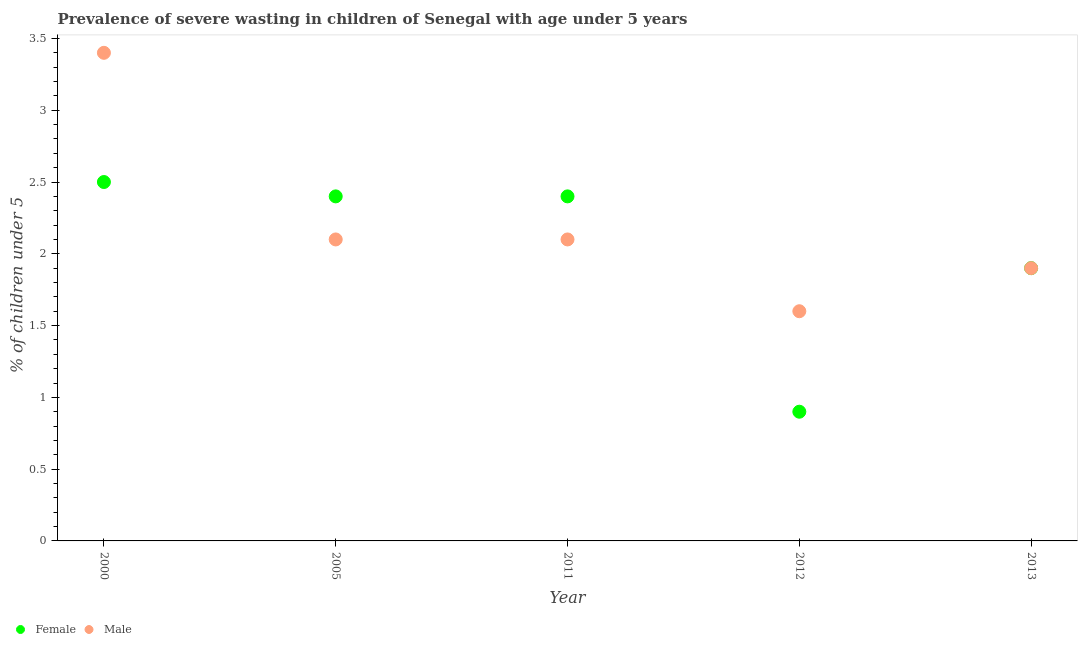Is the number of dotlines equal to the number of legend labels?
Your answer should be compact. Yes. What is the percentage of undernourished male children in 2000?
Give a very brief answer. 3.4. Across all years, what is the maximum percentage of undernourished female children?
Your answer should be very brief. 2.5. Across all years, what is the minimum percentage of undernourished female children?
Provide a short and direct response. 0.9. In which year was the percentage of undernourished male children minimum?
Keep it short and to the point. 2012. What is the total percentage of undernourished male children in the graph?
Give a very brief answer. 11.1. What is the difference between the percentage of undernourished male children in 2005 and that in 2012?
Give a very brief answer. 0.5. What is the difference between the percentage of undernourished male children in 2011 and the percentage of undernourished female children in 2000?
Ensure brevity in your answer.  -0.4. What is the average percentage of undernourished male children per year?
Your answer should be compact. 2.22. In the year 2000, what is the difference between the percentage of undernourished male children and percentage of undernourished female children?
Give a very brief answer. 0.9. In how many years, is the percentage of undernourished female children greater than 2.2 %?
Ensure brevity in your answer.  3. What is the ratio of the percentage of undernourished female children in 2000 to that in 2013?
Offer a very short reply. 1.32. Is the percentage of undernourished female children in 2005 less than that in 2012?
Offer a very short reply. No. Is the difference between the percentage of undernourished female children in 2005 and 2011 greater than the difference between the percentage of undernourished male children in 2005 and 2011?
Provide a succinct answer. No. What is the difference between the highest and the second highest percentage of undernourished male children?
Ensure brevity in your answer.  1.3. What is the difference between the highest and the lowest percentage of undernourished male children?
Ensure brevity in your answer.  1.8. Is the sum of the percentage of undernourished male children in 2005 and 2013 greater than the maximum percentage of undernourished female children across all years?
Ensure brevity in your answer.  Yes. How many dotlines are there?
Give a very brief answer. 2. How many years are there in the graph?
Offer a very short reply. 5. What is the difference between two consecutive major ticks on the Y-axis?
Provide a short and direct response. 0.5. Are the values on the major ticks of Y-axis written in scientific E-notation?
Make the answer very short. No. Does the graph contain grids?
Provide a succinct answer. No. Where does the legend appear in the graph?
Ensure brevity in your answer.  Bottom left. What is the title of the graph?
Your answer should be very brief. Prevalence of severe wasting in children of Senegal with age under 5 years. Does "Non-pregnant women" appear as one of the legend labels in the graph?
Keep it short and to the point. No. What is the label or title of the X-axis?
Keep it short and to the point. Year. What is the label or title of the Y-axis?
Provide a short and direct response.  % of children under 5. What is the  % of children under 5 in Male in 2000?
Offer a terse response. 3.4. What is the  % of children under 5 in Female in 2005?
Keep it short and to the point. 2.4. What is the  % of children under 5 in Male in 2005?
Give a very brief answer. 2.1. What is the  % of children under 5 of Female in 2011?
Make the answer very short. 2.4. What is the  % of children under 5 in Male in 2011?
Provide a short and direct response. 2.1. What is the  % of children under 5 of Female in 2012?
Your answer should be very brief. 0.9. What is the  % of children under 5 in Male in 2012?
Provide a short and direct response. 1.6. What is the  % of children under 5 of Female in 2013?
Provide a succinct answer. 1.9. What is the  % of children under 5 in Male in 2013?
Your answer should be compact. 1.9. Across all years, what is the maximum  % of children under 5 of Male?
Your answer should be compact. 3.4. Across all years, what is the minimum  % of children under 5 of Female?
Ensure brevity in your answer.  0.9. Across all years, what is the minimum  % of children under 5 of Male?
Ensure brevity in your answer.  1.6. What is the total  % of children under 5 of Female in the graph?
Offer a very short reply. 10.1. What is the difference between the  % of children under 5 of Female in 2000 and that in 2005?
Ensure brevity in your answer.  0.1. What is the difference between the  % of children under 5 in Male in 2000 and that in 2005?
Provide a short and direct response. 1.3. What is the difference between the  % of children under 5 in Male in 2000 and that in 2011?
Give a very brief answer. 1.3. What is the difference between the  % of children under 5 of Female in 2000 and that in 2012?
Make the answer very short. 1.6. What is the difference between the  % of children under 5 of Male in 2000 and that in 2012?
Give a very brief answer. 1.8. What is the difference between the  % of children under 5 of Female in 2000 and that in 2013?
Keep it short and to the point. 0.6. What is the difference between the  % of children under 5 in Female in 2005 and that in 2012?
Make the answer very short. 1.5. What is the difference between the  % of children under 5 of Male in 2005 and that in 2012?
Your answer should be very brief. 0.5. What is the difference between the  % of children under 5 of Female in 2005 and that in 2013?
Your answer should be compact. 0.5. What is the difference between the  % of children under 5 in Male in 2005 and that in 2013?
Your answer should be very brief. 0.2. What is the difference between the  % of children under 5 of Female in 2011 and that in 2013?
Your answer should be compact. 0.5. What is the difference between the  % of children under 5 of Male in 2011 and that in 2013?
Ensure brevity in your answer.  0.2. What is the difference between the  % of children under 5 of Male in 2012 and that in 2013?
Offer a very short reply. -0.3. What is the difference between the  % of children under 5 in Female in 2000 and the  % of children under 5 in Male in 2005?
Your answer should be very brief. 0.4. What is the difference between the  % of children under 5 in Female in 2000 and the  % of children under 5 in Male in 2011?
Keep it short and to the point. 0.4. What is the difference between the  % of children under 5 in Female in 2000 and the  % of children under 5 in Male in 2012?
Your response must be concise. 0.9. What is the difference between the  % of children under 5 in Female in 2000 and the  % of children under 5 in Male in 2013?
Offer a terse response. 0.6. What is the difference between the  % of children under 5 in Female in 2005 and the  % of children under 5 in Male in 2011?
Provide a short and direct response. 0.3. What is the difference between the  % of children under 5 in Female in 2005 and the  % of children under 5 in Male in 2013?
Your response must be concise. 0.5. What is the difference between the  % of children under 5 of Female in 2011 and the  % of children under 5 of Male in 2013?
Offer a very short reply. 0.5. What is the average  % of children under 5 in Female per year?
Make the answer very short. 2.02. What is the average  % of children under 5 in Male per year?
Your response must be concise. 2.22. In the year 2011, what is the difference between the  % of children under 5 of Female and  % of children under 5 of Male?
Ensure brevity in your answer.  0.3. In the year 2012, what is the difference between the  % of children under 5 in Female and  % of children under 5 in Male?
Your response must be concise. -0.7. In the year 2013, what is the difference between the  % of children under 5 of Female and  % of children under 5 of Male?
Offer a very short reply. 0. What is the ratio of the  % of children under 5 in Female in 2000 to that in 2005?
Make the answer very short. 1.04. What is the ratio of the  % of children under 5 in Male in 2000 to that in 2005?
Ensure brevity in your answer.  1.62. What is the ratio of the  % of children under 5 in Female in 2000 to that in 2011?
Provide a succinct answer. 1.04. What is the ratio of the  % of children under 5 in Male in 2000 to that in 2011?
Offer a terse response. 1.62. What is the ratio of the  % of children under 5 in Female in 2000 to that in 2012?
Give a very brief answer. 2.78. What is the ratio of the  % of children under 5 of Male in 2000 to that in 2012?
Ensure brevity in your answer.  2.12. What is the ratio of the  % of children under 5 of Female in 2000 to that in 2013?
Your answer should be compact. 1.32. What is the ratio of the  % of children under 5 in Male in 2000 to that in 2013?
Give a very brief answer. 1.79. What is the ratio of the  % of children under 5 in Male in 2005 to that in 2011?
Offer a very short reply. 1. What is the ratio of the  % of children under 5 of Female in 2005 to that in 2012?
Offer a very short reply. 2.67. What is the ratio of the  % of children under 5 of Male in 2005 to that in 2012?
Keep it short and to the point. 1.31. What is the ratio of the  % of children under 5 of Female in 2005 to that in 2013?
Ensure brevity in your answer.  1.26. What is the ratio of the  % of children under 5 of Male in 2005 to that in 2013?
Make the answer very short. 1.11. What is the ratio of the  % of children under 5 of Female in 2011 to that in 2012?
Ensure brevity in your answer.  2.67. What is the ratio of the  % of children under 5 of Male in 2011 to that in 2012?
Provide a short and direct response. 1.31. What is the ratio of the  % of children under 5 in Female in 2011 to that in 2013?
Give a very brief answer. 1.26. What is the ratio of the  % of children under 5 in Male in 2011 to that in 2013?
Provide a succinct answer. 1.11. What is the ratio of the  % of children under 5 of Female in 2012 to that in 2013?
Ensure brevity in your answer.  0.47. What is the ratio of the  % of children under 5 in Male in 2012 to that in 2013?
Offer a terse response. 0.84. What is the difference between the highest and the second highest  % of children under 5 in Female?
Provide a succinct answer. 0.1. What is the difference between the highest and the second highest  % of children under 5 of Male?
Provide a succinct answer. 1.3. What is the difference between the highest and the lowest  % of children under 5 in Female?
Give a very brief answer. 1.6. 